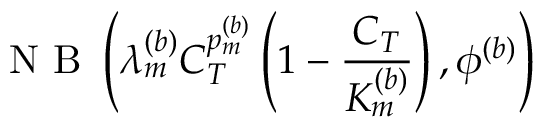Convert formula to latex. <formula><loc_0><loc_0><loc_500><loc_500>N B \left ( \lambda _ { m } ^ { ( b ) } C _ { T } ^ { p _ { m } ^ { ( b ) } } \left ( 1 - \frac { C _ { T } } { K _ { m } ^ { ( b ) } } \right ) , \phi ^ { ( b ) } \right )</formula> 